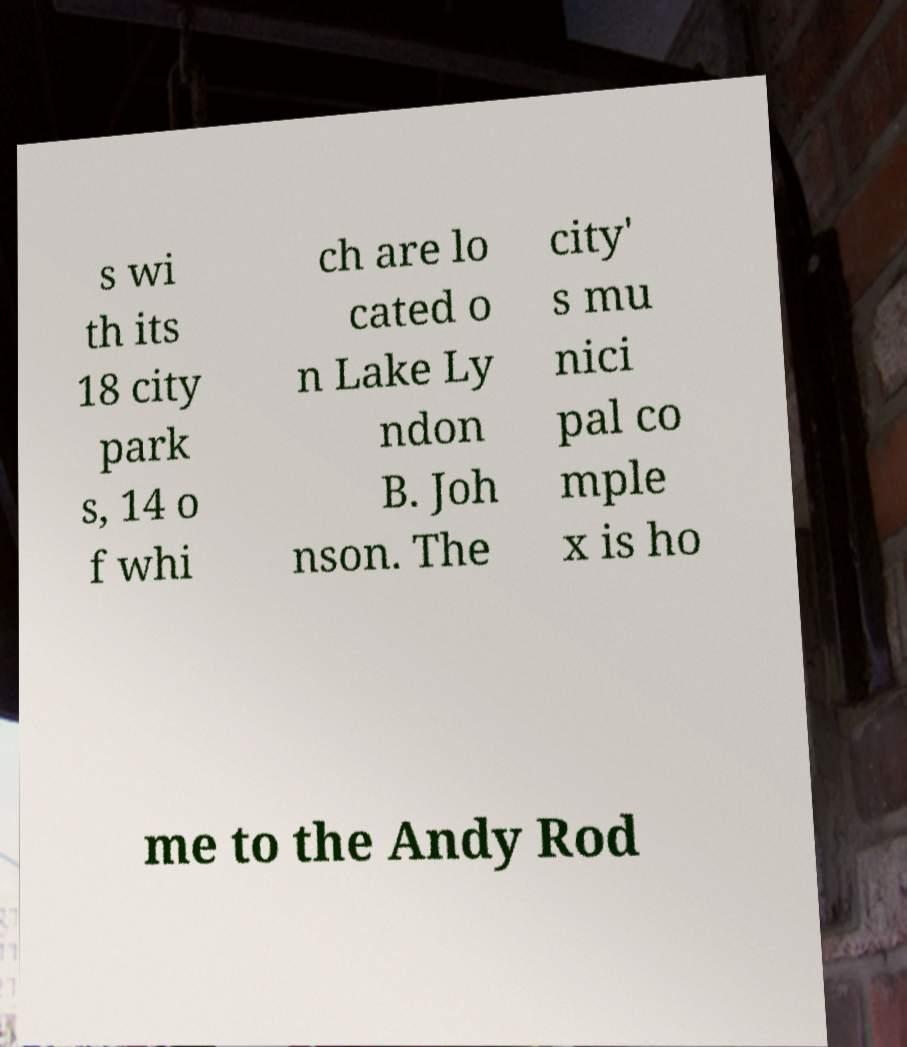Can you accurately transcribe the text from the provided image for me? s wi th its 18 city park s, 14 o f whi ch are lo cated o n Lake Ly ndon B. Joh nson. The city' s mu nici pal co mple x is ho me to the Andy Rod 